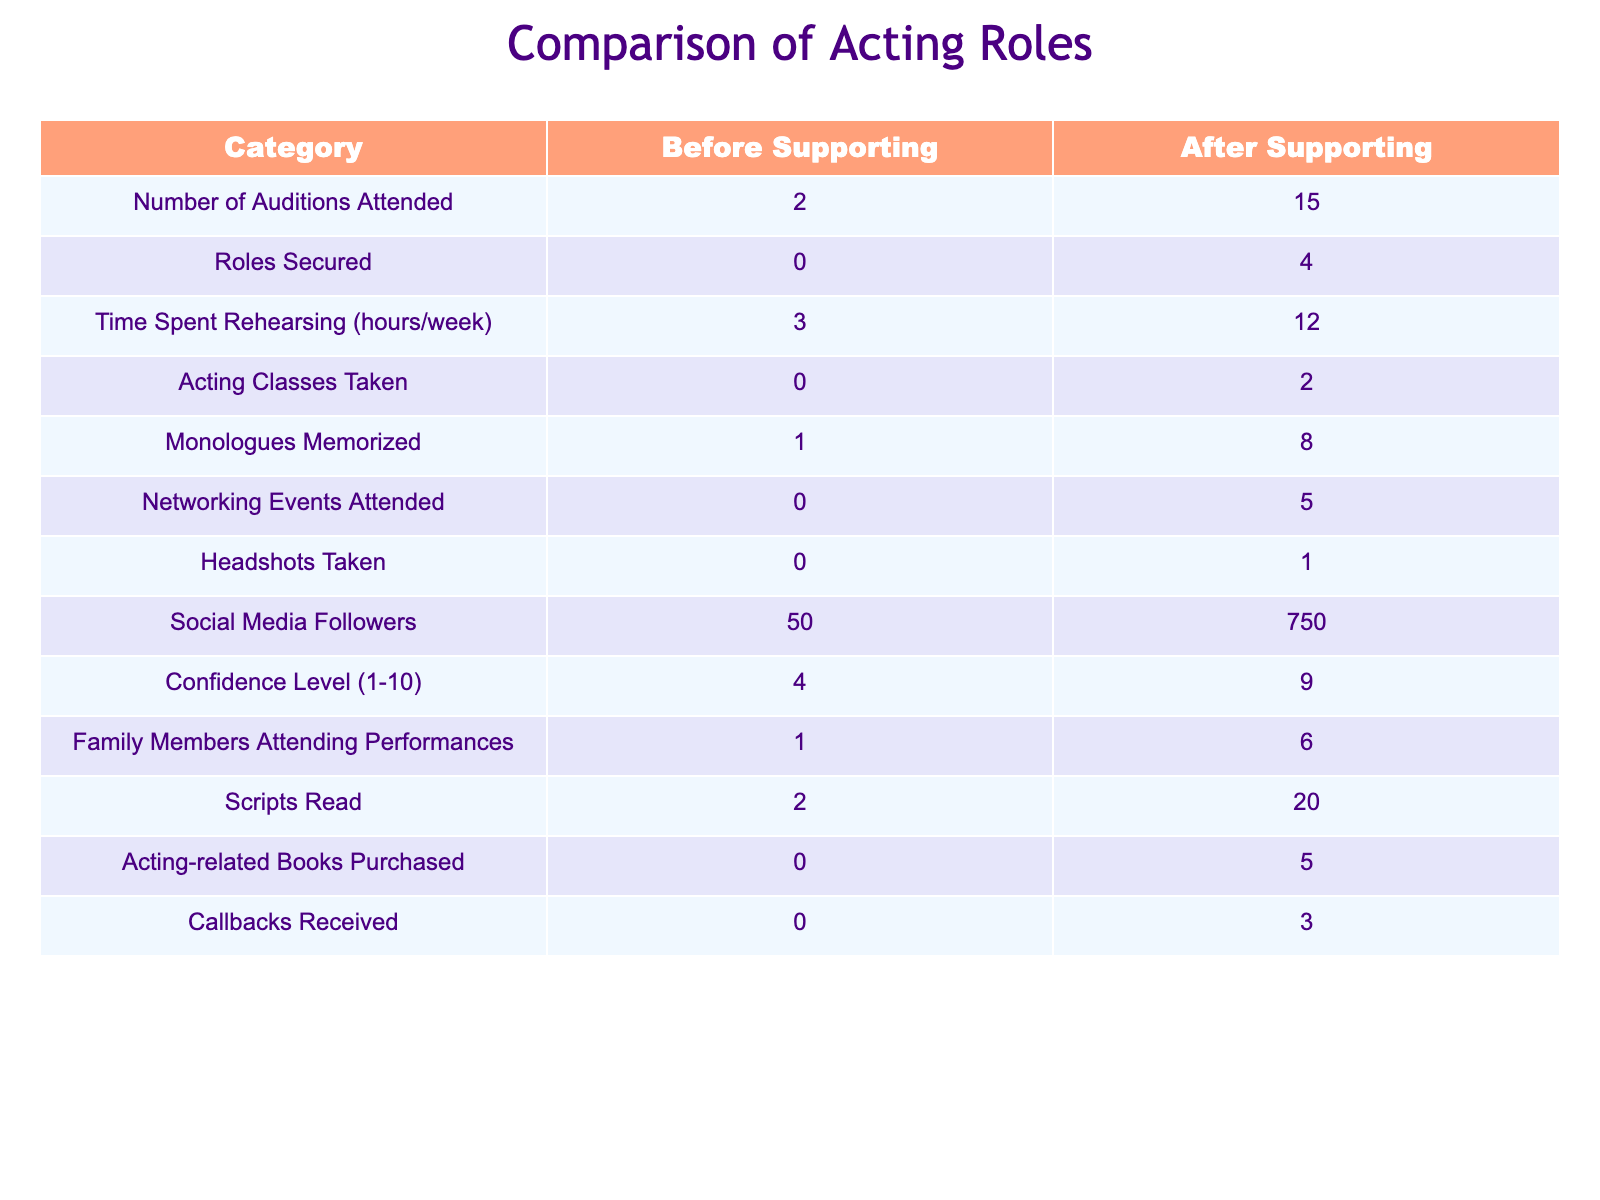What's the total increase in the number of auditions attended after supporting? The number of auditions attended before supporting was 2, and after supporting, it increased to 15. So, the total increase is 15 - 2 = 13.
Answer: 13 How many more roles were secured after I began supporting? Before supporting, there were 0 roles secured, and after supporting, there were 4 roles. The difference is 4 - 0 = 4.
Answer: 4 What is the average number of hours spent rehearsing per week after supporting? After supporting, the time spent rehearsing is 12 hours/week. Since this is a single data point, the average is equal to that value, which is 12.
Answer: 12 Did the student attend any acting classes before I started supporting? According to the table, the number of acting classes taken before supporting is 0. Therefore, it is true that no acting classes were attended.
Answer: No Which category showed the largest growth after supporting? To determine the largest growth, we compare the changes in all categories. The most significant increase is in the number of auditions attended, which went from 2 to 15, a growth of 13.
Answer: Auditions Attended What is the percentage increase in social media followers after supporting? The followers increased from 50 to 750. The increase is 750 - 50 = 700. The percentage increase is (700 / 50) * 100 = 1400%.
Answer: 1400% How many more networking events were attended after I started supporting? Before supporting, the number of networking events attended was 0, and after, it increased to 5. Therefore, the increase is 5 - 0 = 5.
Answer: 5 Was the confidence level higher before supporting or after? The confidence level was 4 before supporting and 9 after supporting. Since 9 is greater than 4, the confidence level was higher after supporting.
Answer: After Supporting What is the total increase in scripts read after supporting? Before supporting, the number of scripts read was 2. After supporting, it increased to 20. Therefore, the total increase is 20 - 2 = 18.
Answer: 18 